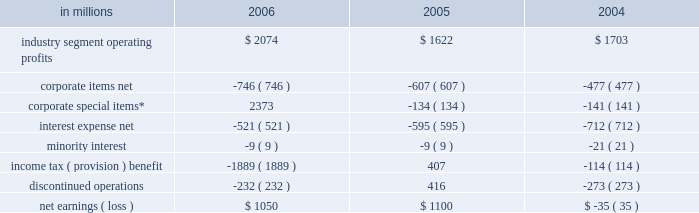Item 7 .
Management 2019s discussion and analysis of financial condition and results of operations executive summary international paper 2019s operating results in 2006 bene- fited from strong gains in pricing and sales volumes and lower operating costs .
Our average paper and packaging prices in 2006 increased faster than our costs for the first time in four years .
The improve- ment in sales volumes reflects increased uncoated papers , corrugated box , coated paperboard and european papers shipments , as well as improved revenues from our xpedx distribution business .
Our manufacturing operations also made solid cost reduction improvements .
Lower interest expense , reflecting debt repayments in 2005 and 2006 , was also a positive factor .
Together , these improvements more than offset the effects of continued high raw material and distribution costs , lower real estate sales , higher net corporate expenses and lower con- tributions from businesses and forestlands divested during 2006 .
Looking forward to 2007 , we expect seasonally higher sales volumes in the first quarter .
Average paper price realizations should continue to improve as we implement previously announced price increases in europe and brazil .
Input costs for energy , fiber and chemicals are expected to be mixed , although slightly higher in the first quarter .
Operating results will benefit from the recently completed international paper/sun paperboard joint ventures in china and the addition of the luiz anto- nio paper mill to our operations in brazil .
However , primarily as a result of lower real estate sales in the first quarter , we anticipate earnings from continuing operations will be somewhat lower than in the 2006 fourth quarter .
Significant steps were also taken in 2006 in the execution of the company 2019s transformation plan .
We completed the sales of our u.s .
And brazilian coated papers businesses and 5.6 million acres of u.s .
Forestlands , and announced definitive sale agreements for our kraft papers , beverage pack- aging and arizona chemical businesses and a majority of our wood products business , all expected to close during 2007 .
Through december 31 , 2006 , we have received approximately $ 9.7 billion of the estimated proceeds from divest- itures announced under this plan of approximately $ 11.3 billion , with the balance to be received as the remaining divestitures are completed in the first half of 2007 .
We have strengthened our balance sheet by reducing debt by $ 6.2 billion , and returned value to our shareholders by repurchasing 39.7 million shares of our common stock for approximately $ 1.4 billion .
We made a $ 1.0 billion voluntary contribution to our u.s .
Qualified pension fund .
We have identified selective reinvestment opportunities totaling approx- imately $ 2.0 billion , including opportunities in china , brazil and russia .
Finally , we remain focused on our three-year $ 1.2 billion target for non-price profit- ability improvements , with $ 330 million realized during 2006 .
While more remains to be done in 2007 , we have made substantial progress toward achiev- ing the objectives announced at the outset of the plan in july 2005 .
Results of operations industry segment operating profits are used by inter- national paper 2019s management to measure the earn- ings performance of its businesses .
Management believes that this measure allows a better under- standing of trends in costs , operating efficiencies , prices and volumes .
Industry segment operating profits are defined as earnings before taxes and minority interest , interest expense , corporate items and corporate special items .
Industry segment oper- ating profits are defined by the securities and exchange commission as a non-gaap financial measure , and are not gaap alternatives to net income or any other operating measure prescribed by accounting principles generally accepted in the united states .
International paper operates in six segments : print- ing papers , industrial packaging , consumer pack- aging , distribution , forest products and specialty businesses and other .
The table shows the components of net earnings ( loss ) for each of the last three years : in millions 2006 2005 2004 .
* corporate special items include gains on transformation plan forestland sales , goodwill impairment charges , restructuring and other charges , net losses on sales and impairments of businesses , insurance recoveries and reversals of reserves no longer required. .
What was the ratio of the debt reduction to the stock repurchase? 
Computations: (6.2 / 1.4)
Answer: 4.42857. 